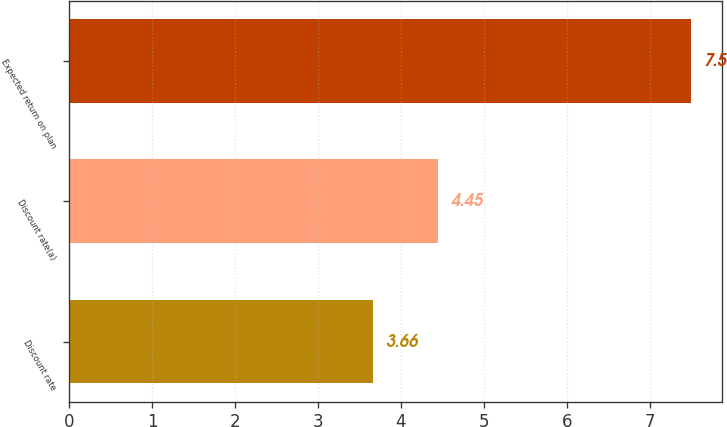<chart> <loc_0><loc_0><loc_500><loc_500><bar_chart><fcel>Discount rate<fcel>Discount rate(a)<fcel>Expected return on plan<nl><fcel>3.66<fcel>4.45<fcel>7.5<nl></chart> 